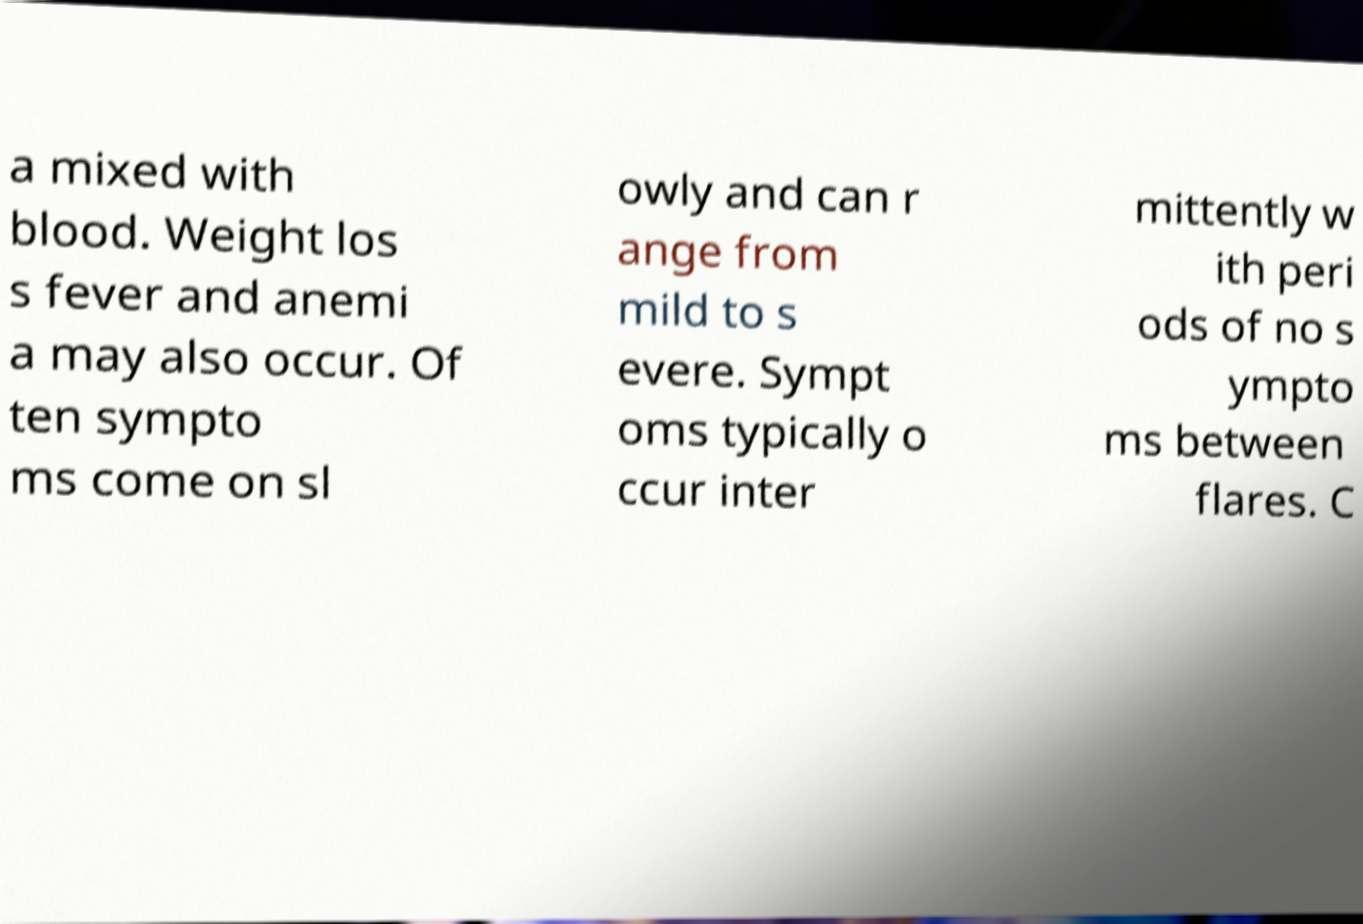Can you read and provide the text displayed in the image?This photo seems to have some interesting text. Can you extract and type it out for me? a mixed with blood. Weight los s fever and anemi a may also occur. Of ten sympto ms come on sl owly and can r ange from mild to s evere. Sympt oms typically o ccur inter mittently w ith peri ods of no s ympto ms between flares. C 